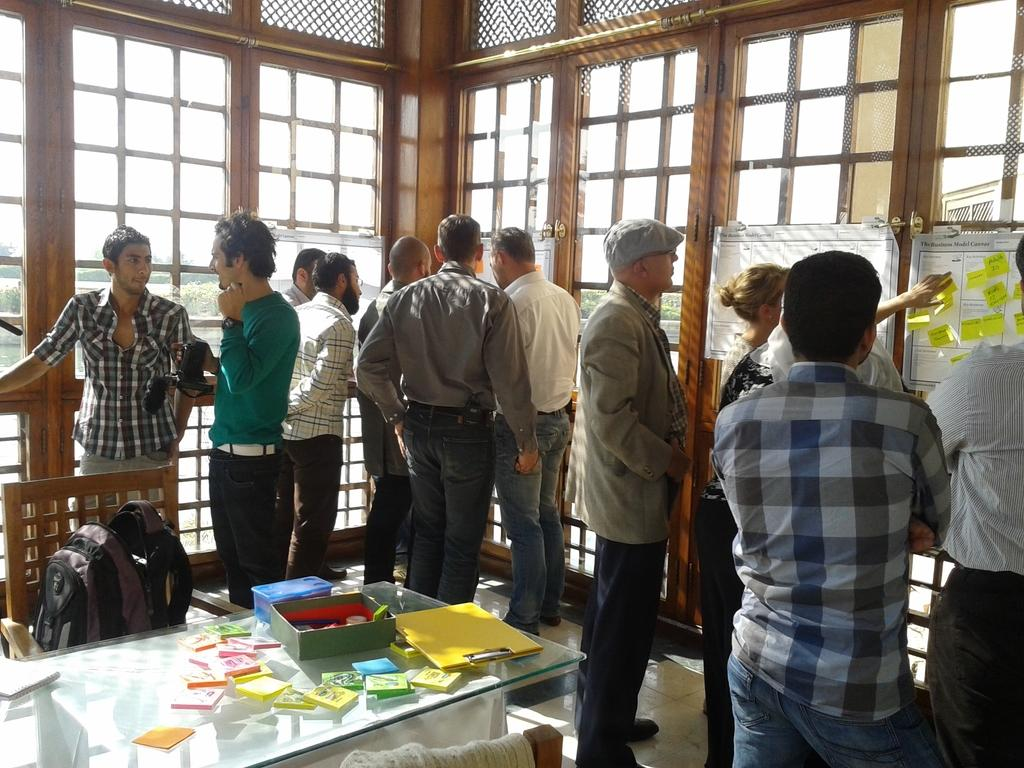What is happening in the image? There are people standing in the image. What object can be seen in the image that might be used for holding or displaying items? There is a table in the image. What items are on the table? There are booklets and a pad on the table. Are there any women standing near a volcano in the image? There is no mention of women or a volcano in the image; it only shows people standing near a table with booklets and a pad. 